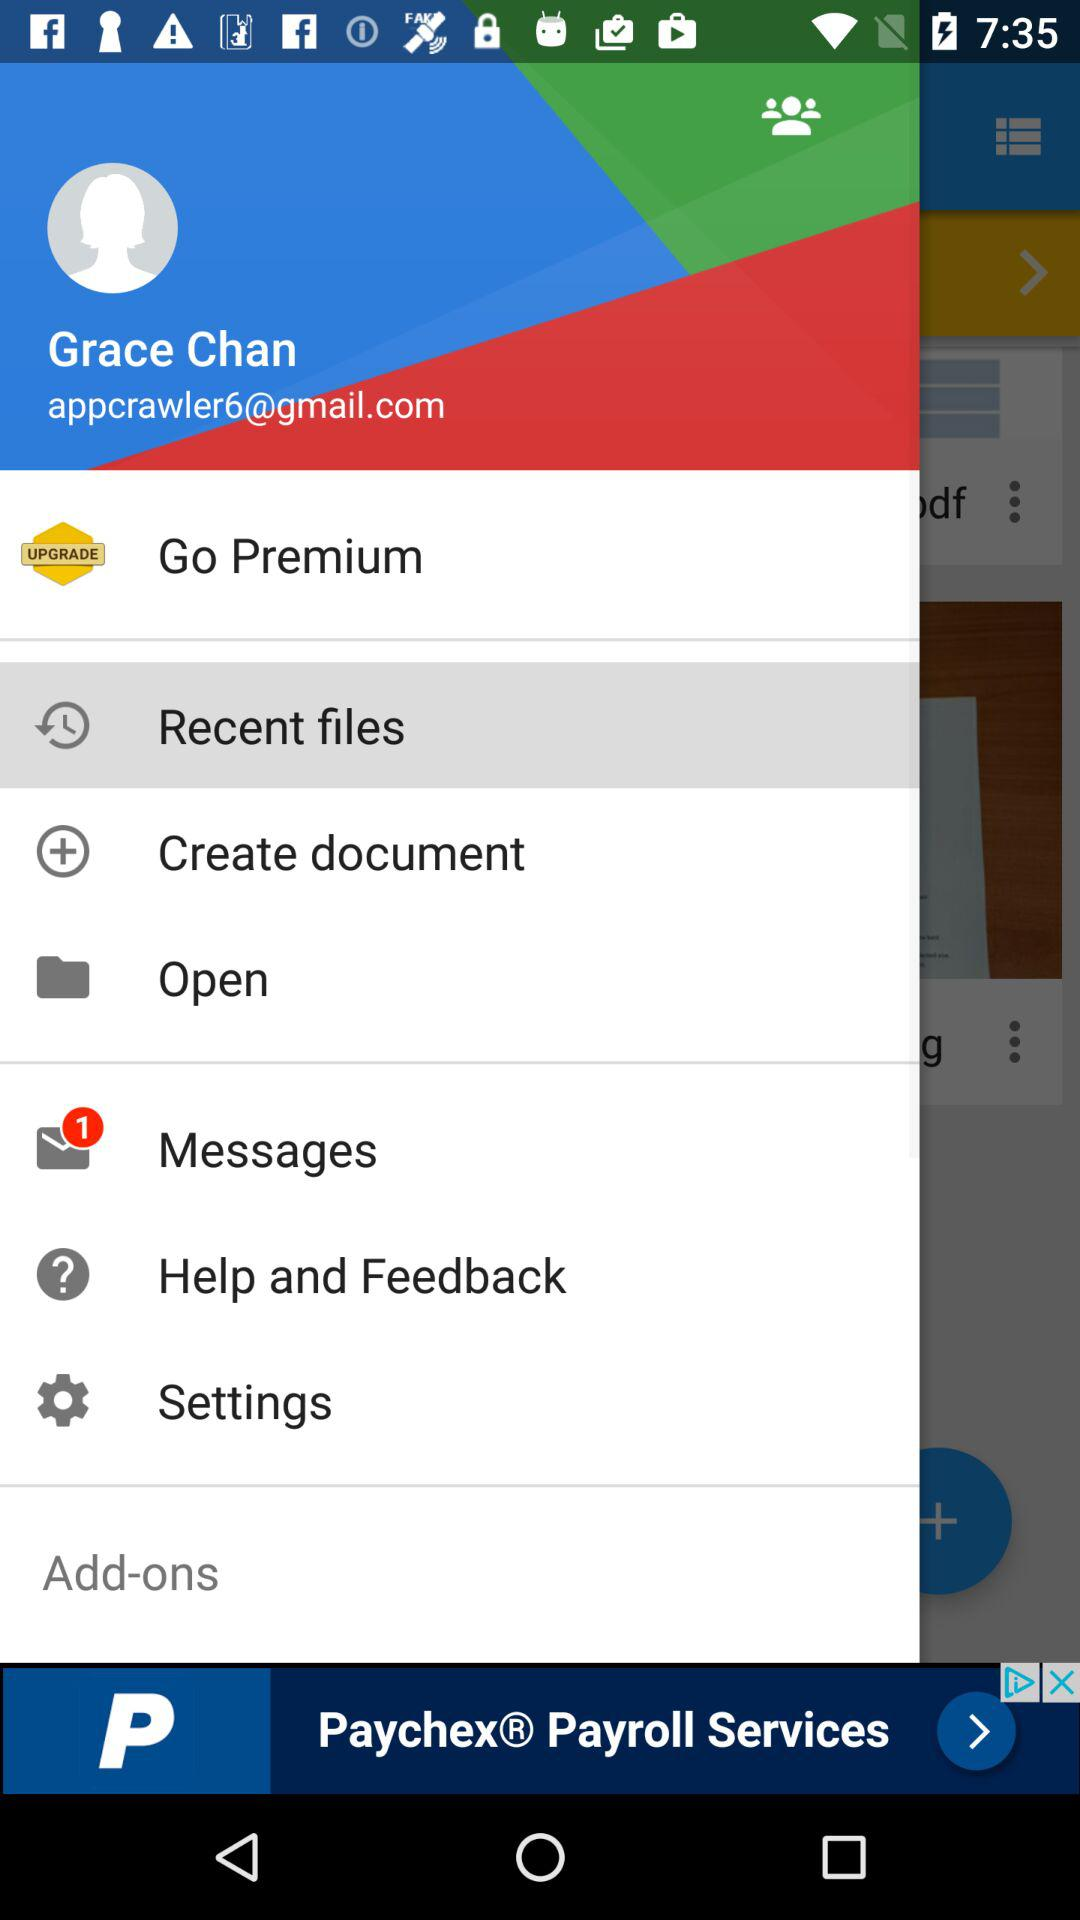What is the email address? The email address is appcrawler6@gmail.com. 